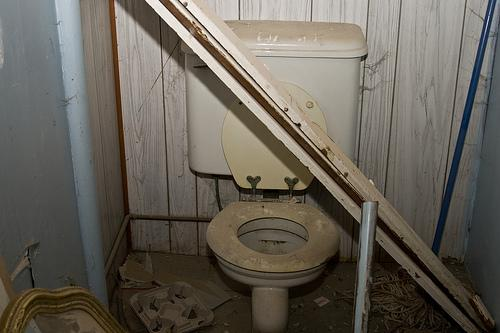Can you identify any objects leaning against the toilet? Pieces of wood are leaning over the toilet. Please provide a brief description of the condition of the bathroom. The bathroom looks very dirty and has a very old appearance with dirt on the toilet and a super dirty mop head. Describe the condition and color of the toilet seat in the image. The toilet seat is dirty, white, and brown in color. Identify the color and material of the wall behind the toilet. The wall behind the toilet is tan and brown in color and made of wooden panels. Explain the condition of the wall in the image and its color. The wall is white in color and is clean. What is the primary purpose of the room in the image? The primary purpose of the room is as a bathroom. How many distinct objects can you count in the bathroom? There are 12 distinct objects in the bathroom. Describe the mop found in the bathroom, including its handle and woolen part. The mop has a blue handle and a super dirty woolen part, and it is situated in the corner of the room. What kind of object is located on the bathroom floor? A brownish card board cup holder is located on the bathroom floor. What action is happening in the image? No activity Identify any events taking place in this scene. No events are occurring Is there a purple water pipe connected to the toilet bowl? The water pipe connected to the toilet bowl is not described as having any color, but it's unlikely that it would be purple. Describe the mop and its position in the bathroom. The mop is super dirty and has a blue handle. It is located in the corner of the room. Can you see a sparkling clean bathroom in the image? The image is described as having a very old looking bathroom and being very dirty. Examine if there is any sadness or happiness in people's faces in the image. No people in the image Is the toilet seat bright and shiny white in color? The actual toilet seat is described as dirty white and brown, and having dirt on it. Describe the bathroom scene in a poetic style. In a room of forgotten grime, a weary toilet stands, adorned with stained white and tan hues, shadowed by a wooden wall aging with time. Imagine a dialogue between the toilet and the mop in the bathroom. Toilet: "Oh mop, how have we come to this? Abandoned and stained with dirt..." Can you find the green wooden wall behind the toilet in the image? The wooden wall behind the toilet is described as tan and brown in color, not green. Does the mop in the bathroom have a red handle? The mop handle in the bathroom is described as blue, not red. Is there a silver picture frame on the floor near the wall? The picture frame on the floor is described as off white and gold, not silver. Are there any broken or malfunctioning objects in the image? Not visible in the image Which item in the bathroom is leaning against the wall? Fallen gold picture frame Describe the image using a spooky tone. In the murky depths of a forsaken bathroom, an eerie toilet stands, its once-pristine hue now tainted by the sinister touch of grime, as shadows dance upon the ancient wooden walls. Are there any celebrations or gatherings happening in this scene? No Create a short story based on the objects in the bathroom. Once in a dusty old bathroom, a dirty mop found solace in the quiet corner, pondering its life beside a long-forgotten cup holder. Amidst the wooden walls, the neglected toilet sighed as it noticed a fallen gold frame, seeking a purpose in their shared abandonment. List any numbers or letters present in the image. No numbers or letters Explain the layout of the bathroom, including fixtures and objects. An old bathroom with a dirty, white and tan toilet, a mop in the corner, wood paneling on the wall, a cup holder on the floor, and pieces of wood leaning over the toilet. Does the bathroom appear to be clean or dirty? Dirty Summarize the objects in the scene and their positions. Dirty bathroom with a stained toilet and white wood panel wall, a gold picture frame on the floor, a dirty mop in the corner, and a cardboard cup holder also on the floor. Identify any text visible in the image. No text present What color is the toilet seat in the bathroom? Dirty white and brown 